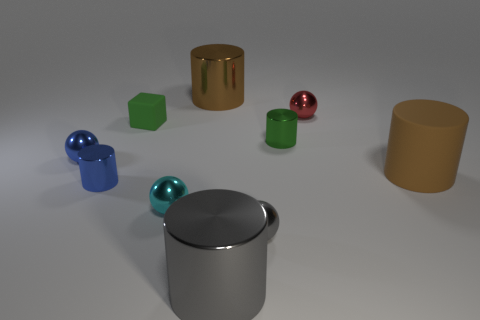Subtract all blue cylinders. How many cylinders are left? 4 Subtract all rubber cylinders. How many cylinders are left? 4 Subtract 1 gray spheres. How many objects are left? 9 Subtract all balls. How many objects are left? 6 Subtract 3 cylinders. How many cylinders are left? 2 Subtract all gray spheres. Subtract all gray cylinders. How many spheres are left? 3 Subtract all green cylinders. How many gray spheres are left? 1 Subtract all blue metal things. Subtract all rubber cubes. How many objects are left? 7 Add 4 small gray objects. How many small gray objects are left? 5 Add 8 big matte cylinders. How many big matte cylinders exist? 9 